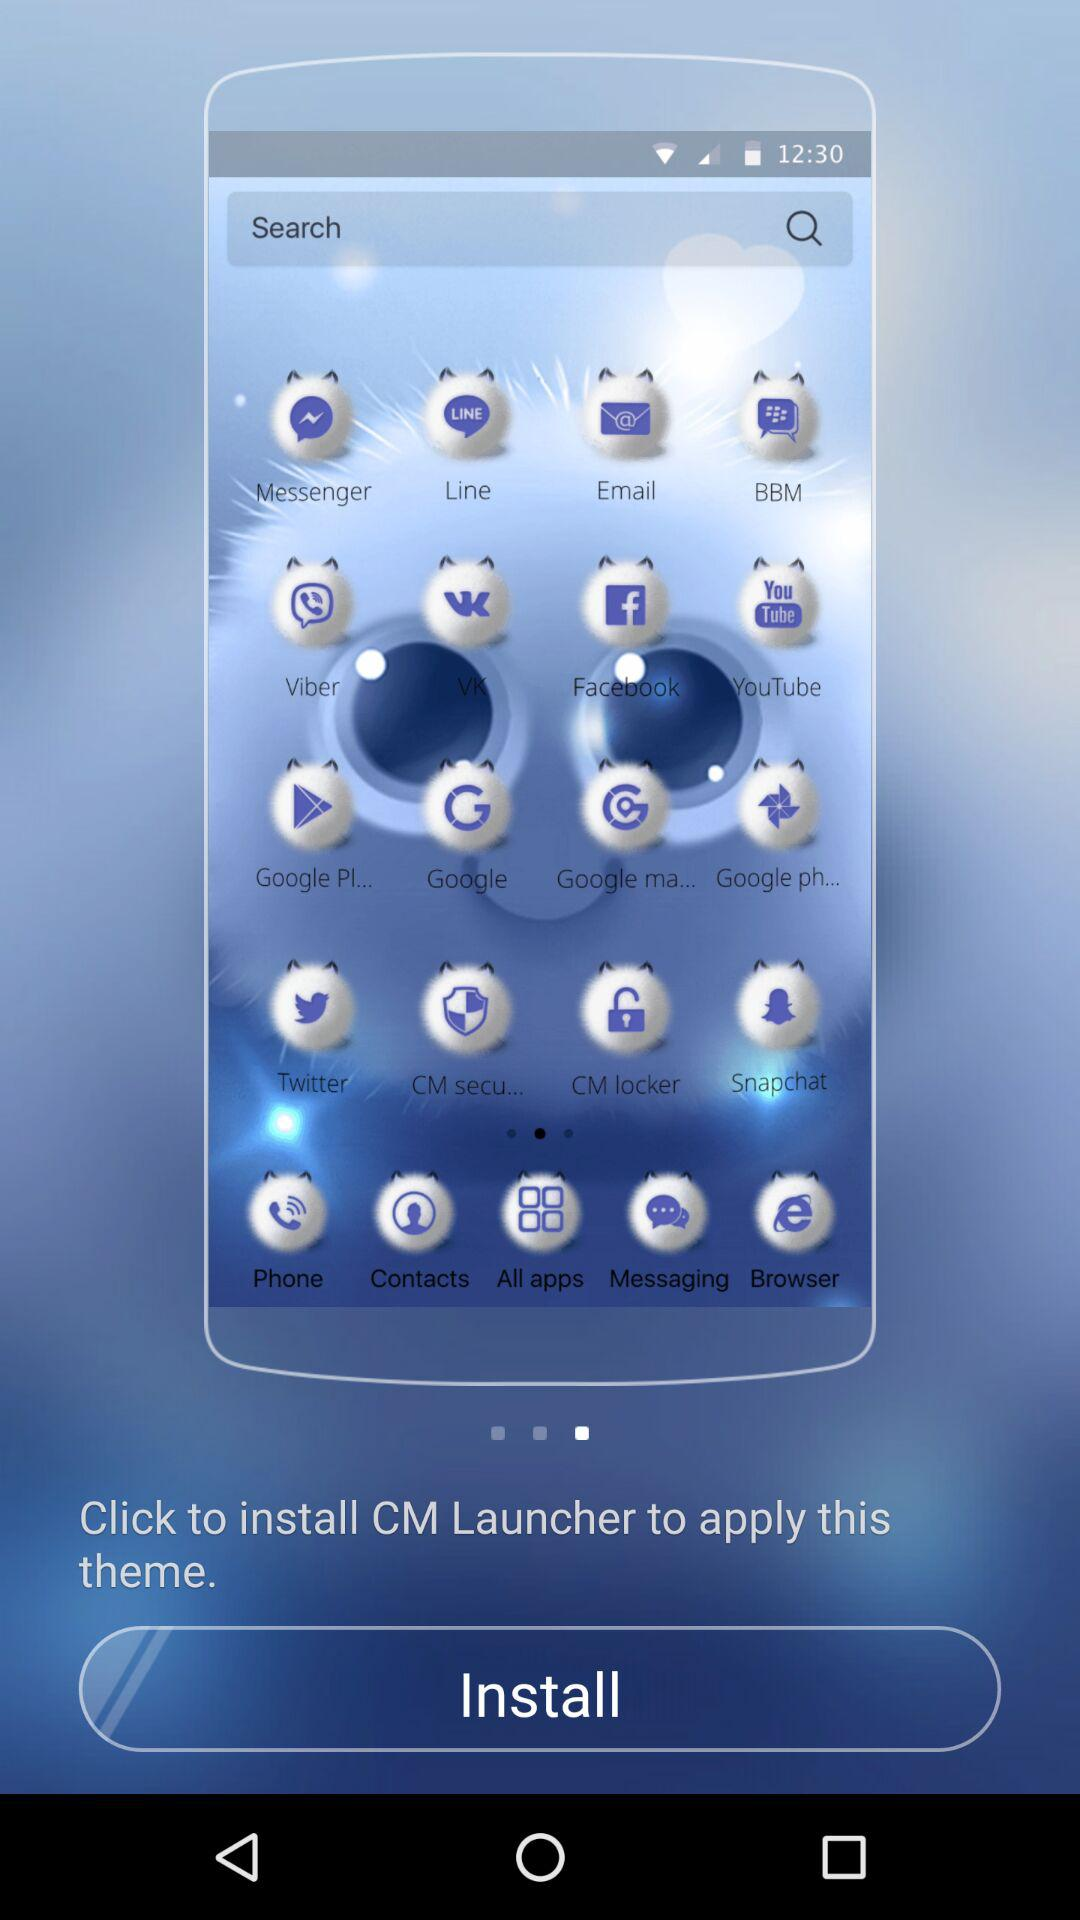What do I need to install to apply this theme? You need to install "CM Launcher" to apply this theme. 